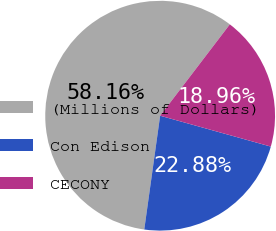Convert chart. <chart><loc_0><loc_0><loc_500><loc_500><pie_chart><fcel>(Millions of Dollars)<fcel>Con Edison<fcel>CECONY<nl><fcel>58.17%<fcel>22.88%<fcel>18.96%<nl></chart> 